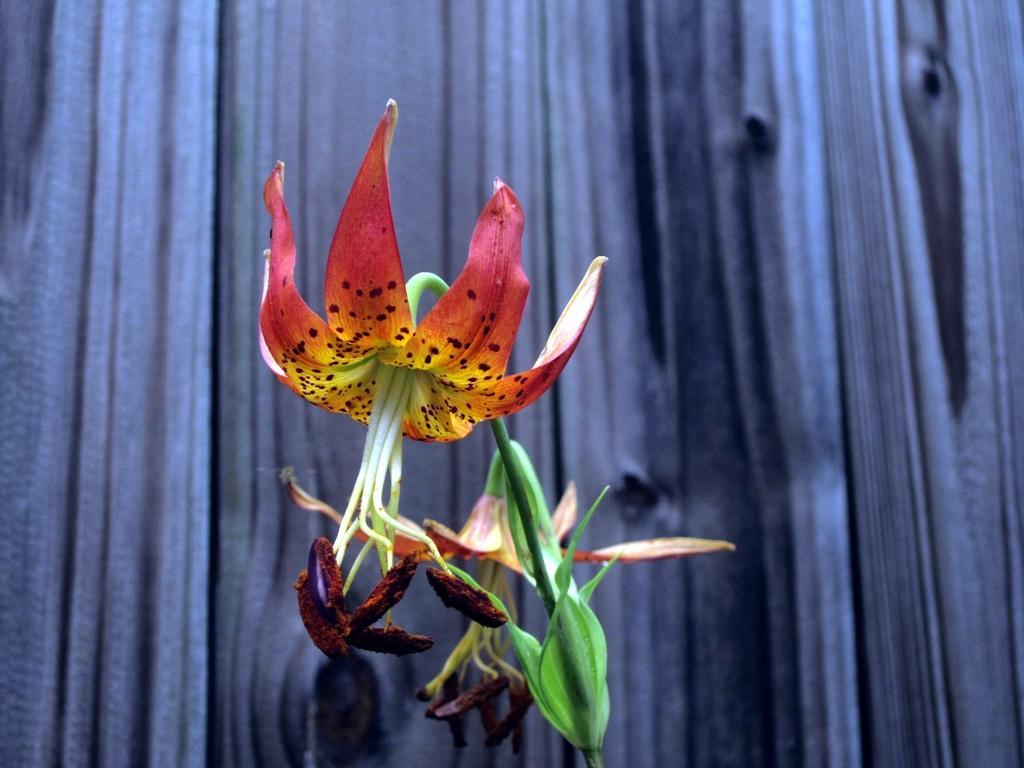Describe this image in one or two sentences. In this image in the foreground there are some flowers, and in the background there is a wall. 